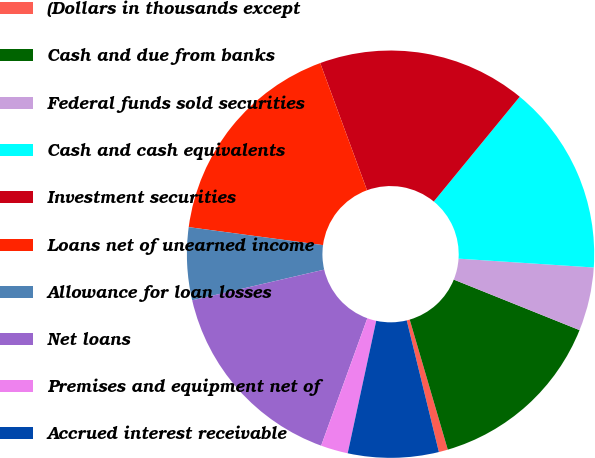Convert chart to OTSL. <chart><loc_0><loc_0><loc_500><loc_500><pie_chart><fcel>(Dollars in thousands except<fcel>Cash and due from banks<fcel>Federal funds sold securities<fcel>Cash and cash equivalents<fcel>Investment securities<fcel>Loans net of unearned income<fcel>Allowance for loan losses<fcel>Net loans<fcel>Premises and equipment net of<fcel>Accrued interest receivable<nl><fcel>0.72%<fcel>14.39%<fcel>5.04%<fcel>15.11%<fcel>16.55%<fcel>17.27%<fcel>5.76%<fcel>15.83%<fcel>2.16%<fcel>7.19%<nl></chart> 